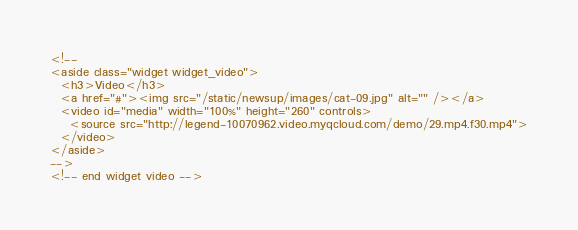<code> <loc_0><loc_0><loc_500><loc_500><_HTML_><!--
<aside class="widget widget_video">
  <h3>Video</h3>
  <a href="#"><img src="/static/newsup/images/cat-09.jpg" alt="" /></a>
  <video id="media" width="100%" height="260" controls>
    <source src="http://legend-10070962.video.myqcloud.com/demo/29.mp4.f30.mp4">
  </video>
</aside>
-->
<!-- end widget video -->
</code> 